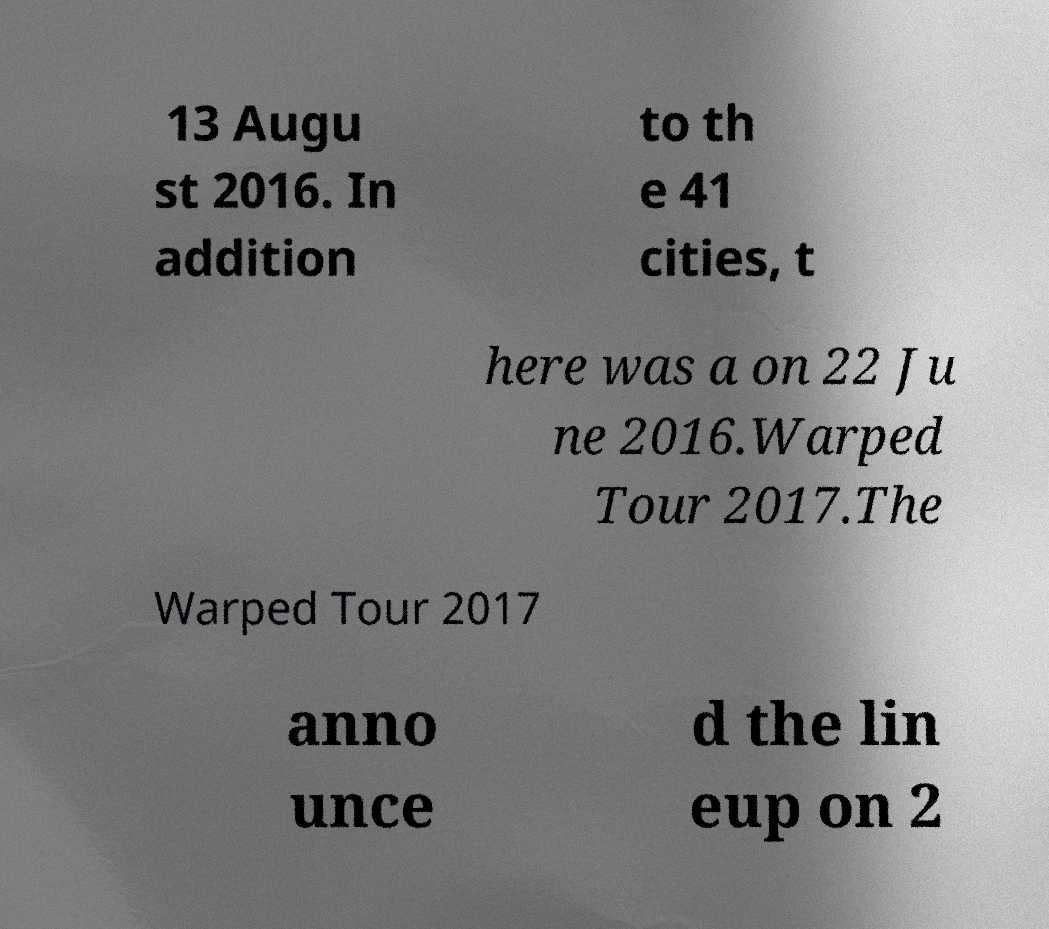Can you read and provide the text displayed in the image?This photo seems to have some interesting text. Can you extract and type it out for me? 13 Augu st 2016. In addition to th e 41 cities, t here was a on 22 Ju ne 2016.Warped Tour 2017.The Warped Tour 2017 anno unce d the lin eup on 2 